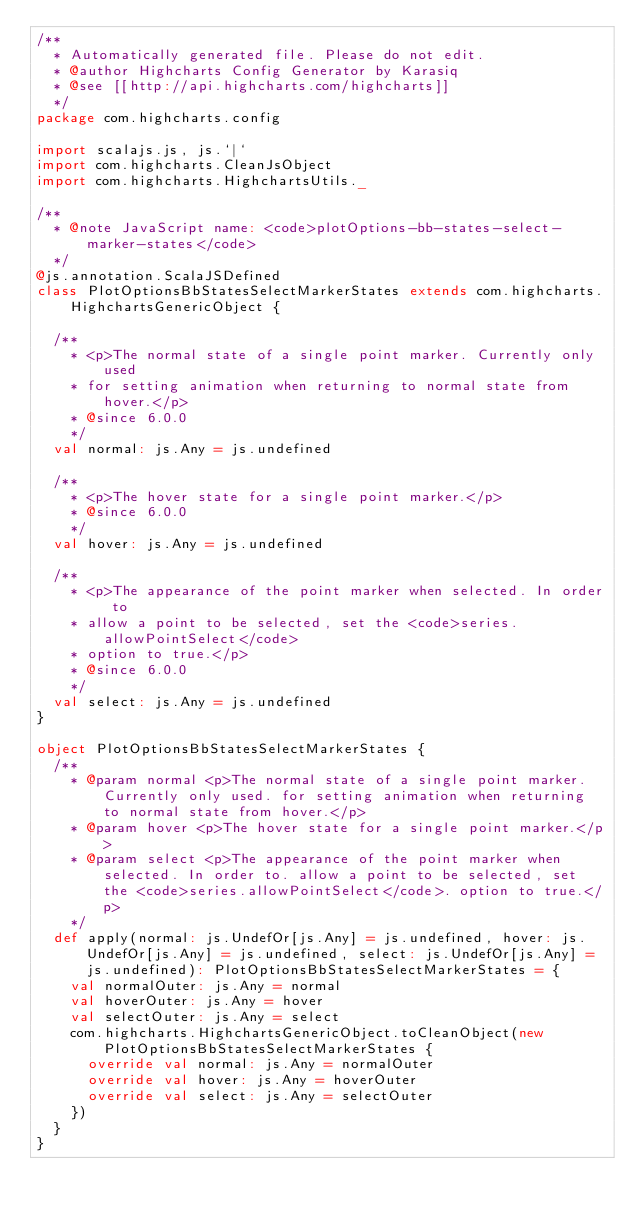<code> <loc_0><loc_0><loc_500><loc_500><_Scala_>/**
  * Automatically generated file. Please do not edit.
  * @author Highcharts Config Generator by Karasiq
  * @see [[http://api.highcharts.com/highcharts]]
  */
package com.highcharts.config

import scalajs.js, js.`|`
import com.highcharts.CleanJsObject
import com.highcharts.HighchartsUtils._

/**
  * @note JavaScript name: <code>plotOptions-bb-states-select-marker-states</code>
  */
@js.annotation.ScalaJSDefined
class PlotOptionsBbStatesSelectMarkerStates extends com.highcharts.HighchartsGenericObject {

  /**
    * <p>The normal state of a single point marker. Currently only used
    * for setting animation when returning to normal state from hover.</p>
    * @since 6.0.0
    */
  val normal: js.Any = js.undefined

  /**
    * <p>The hover state for a single point marker.</p>
    * @since 6.0.0
    */
  val hover: js.Any = js.undefined

  /**
    * <p>The appearance of the point marker when selected. In order to
    * allow a point to be selected, set the <code>series.allowPointSelect</code>
    * option to true.</p>
    * @since 6.0.0
    */
  val select: js.Any = js.undefined
}

object PlotOptionsBbStatesSelectMarkerStates {
  /**
    * @param normal <p>The normal state of a single point marker. Currently only used. for setting animation when returning to normal state from hover.</p>
    * @param hover <p>The hover state for a single point marker.</p>
    * @param select <p>The appearance of the point marker when selected. In order to. allow a point to be selected, set the <code>series.allowPointSelect</code>. option to true.</p>
    */
  def apply(normal: js.UndefOr[js.Any] = js.undefined, hover: js.UndefOr[js.Any] = js.undefined, select: js.UndefOr[js.Any] = js.undefined): PlotOptionsBbStatesSelectMarkerStates = {
    val normalOuter: js.Any = normal
    val hoverOuter: js.Any = hover
    val selectOuter: js.Any = select
    com.highcharts.HighchartsGenericObject.toCleanObject(new PlotOptionsBbStatesSelectMarkerStates {
      override val normal: js.Any = normalOuter
      override val hover: js.Any = hoverOuter
      override val select: js.Any = selectOuter
    })
  }
}
</code> 